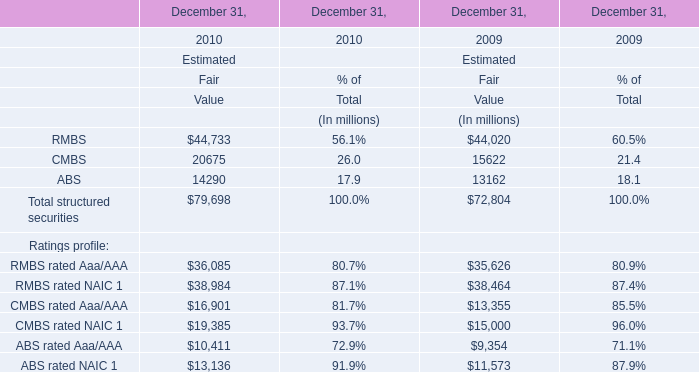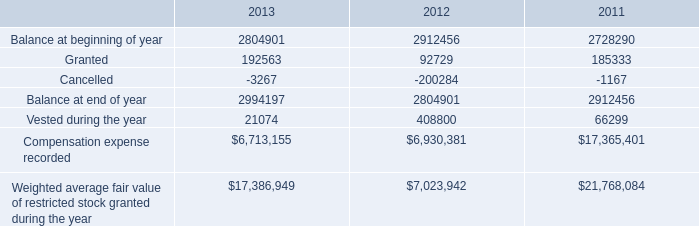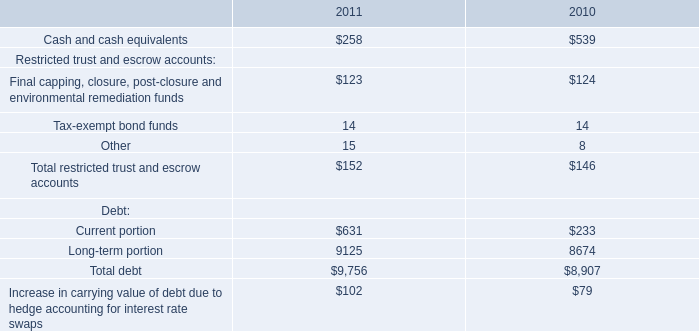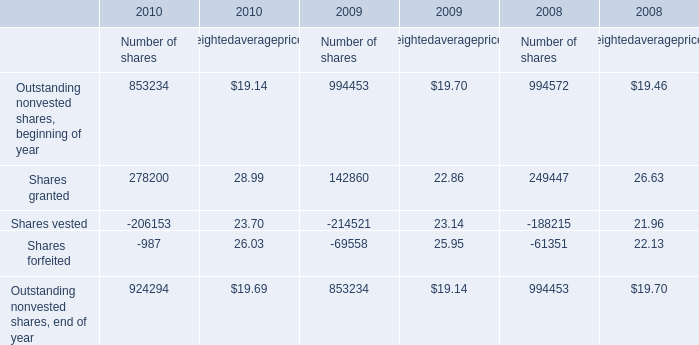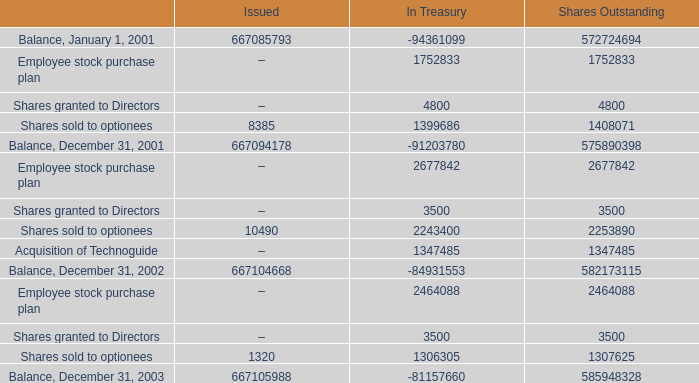What is the total amount of Balance, December 31, 2001 of Issued, and ABS of December 31, 2010 Estimated Fair Value ? 
Computations: (667094178.0 + 14290.0)
Answer: 667108468.0. 